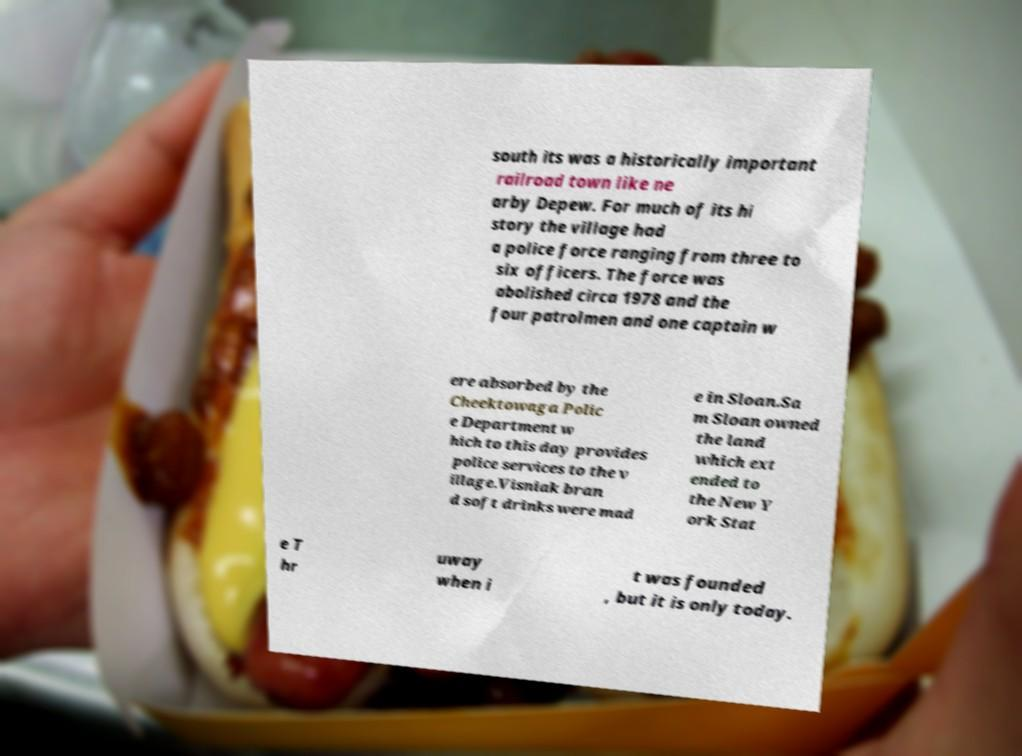Please identify and transcribe the text found in this image. south its was a historically important railroad town like ne arby Depew. For much of its hi story the village had a police force ranging from three to six officers. The force was abolished circa 1978 and the four patrolmen and one captain w ere absorbed by the Cheektowaga Polic e Department w hich to this day provides police services to the v illage.Visniak bran d soft drinks were mad e in Sloan.Sa m Sloan owned the land which ext ended to the New Y ork Stat e T hr uway when i t was founded , but it is only today. 